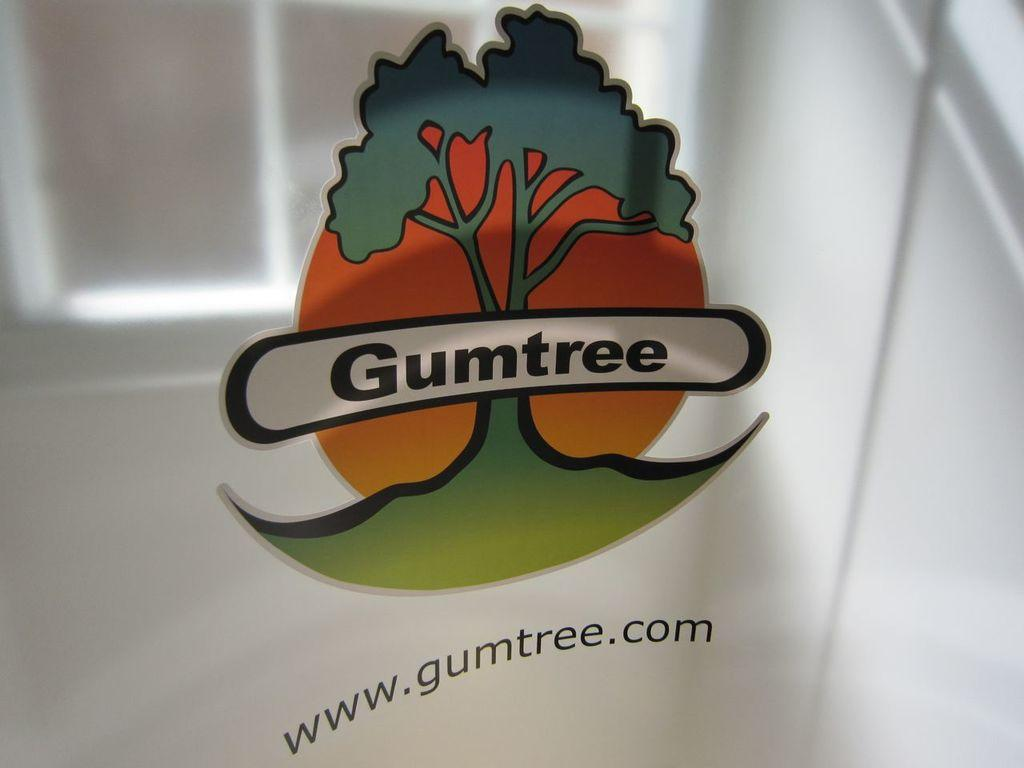What is the main object in the image? There is a log in the image. What is the log resting on? The log is on a glass surface. Is there any text associated with the log? Yes, there is text under the log. What type of alarm is going off in the image? There is no alarm present in the image; it only features a log on a glass surface with text underneath. 